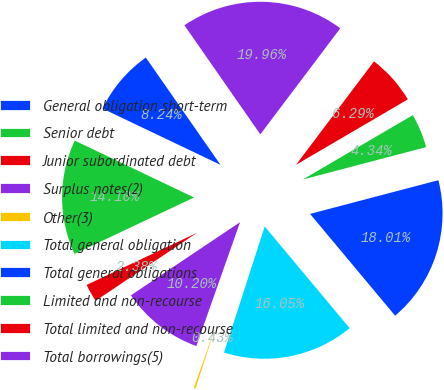Convert chart to OTSL. <chart><loc_0><loc_0><loc_500><loc_500><pie_chart><fcel>General obligation short-term<fcel>Senior debt<fcel>Junior subordinated debt<fcel>Surplus notes(2)<fcel>Other(3)<fcel>Total general obligation<fcel>Total general obligations<fcel>Limited and non-recourse<fcel>Total limited and non-recourse<fcel>Total borrowings(5)<nl><fcel>8.24%<fcel>14.1%<fcel>2.38%<fcel>10.2%<fcel>0.43%<fcel>16.05%<fcel>18.01%<fcel>4.34%<fcel>6.29%<fcel>19.96%<nl></chart> 